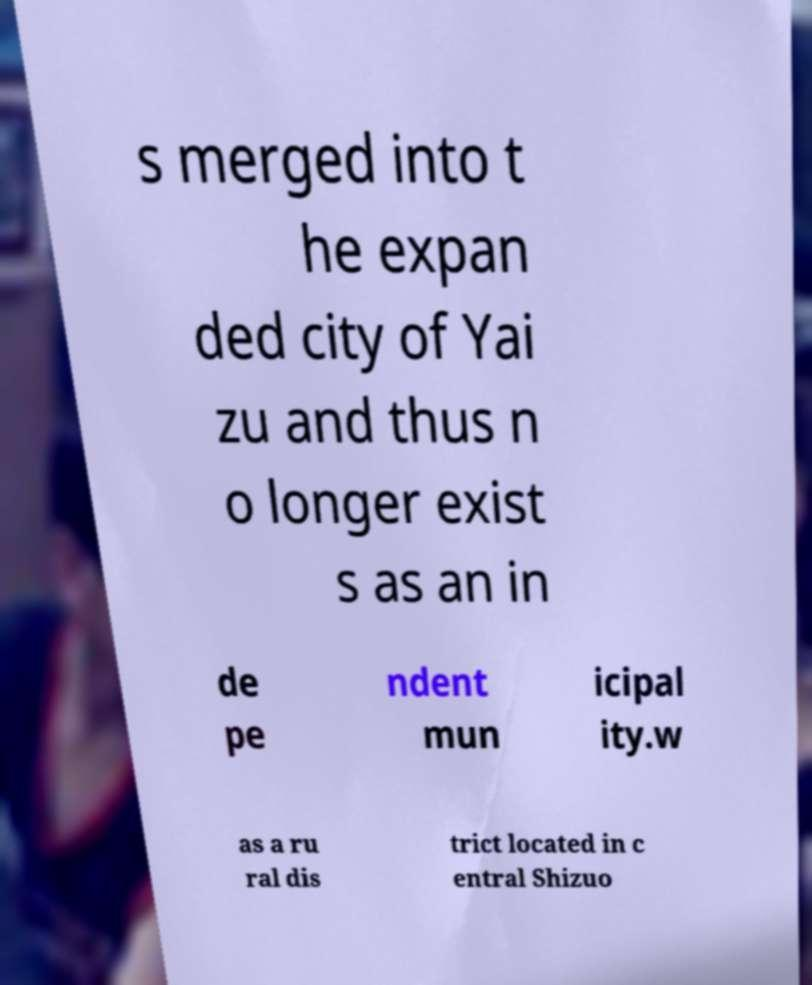Can you read and provide the text displayed in the image?This photo seems to have some interesting text. Can you extract and type it out for me? s merged into t he expan ded city of Yai zu and thus n o longer exist s as an in de pe ndent mun icipal ity.w as a ru ral dis trict located in c entral Shizuo 